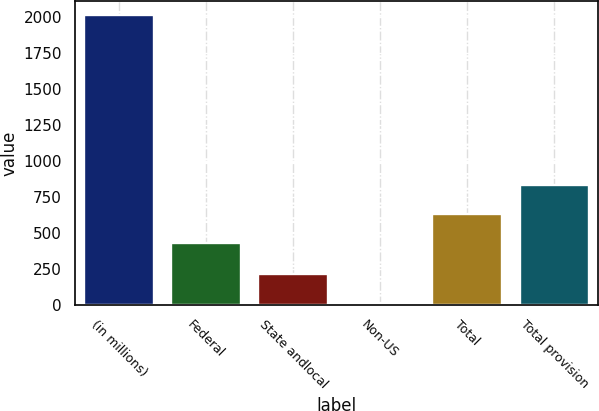Convert chart. <chart><loc_0><loc_0><loc_500><loc_500><bar_chart><fcel>(in millions)<fcel>Federal<fcel>State andlocal<fcel>Non-US<fcel>Total<fcel>Total provision<nl><fcel>2010<fcel>429.4<fcel>211.53<fcel>11.7<fcel>629.23<fcel>829.06<nl></chart> 